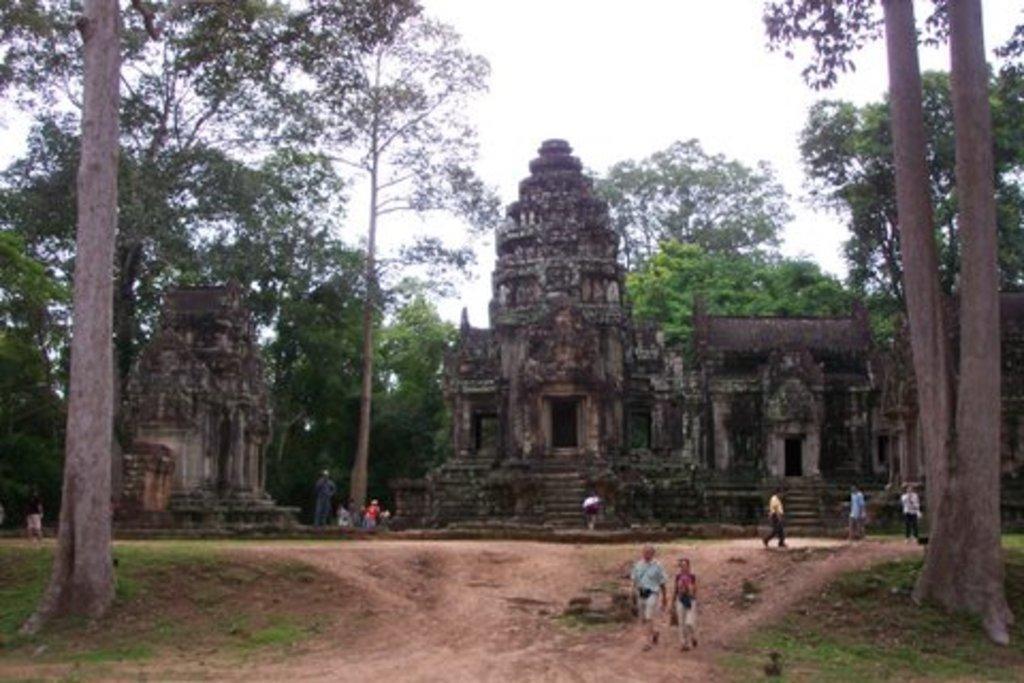In one or two sentences, can you explain what this image depicts? In this picture we can see a temple surrounded with many trees. There are tourists walking on the ground. 